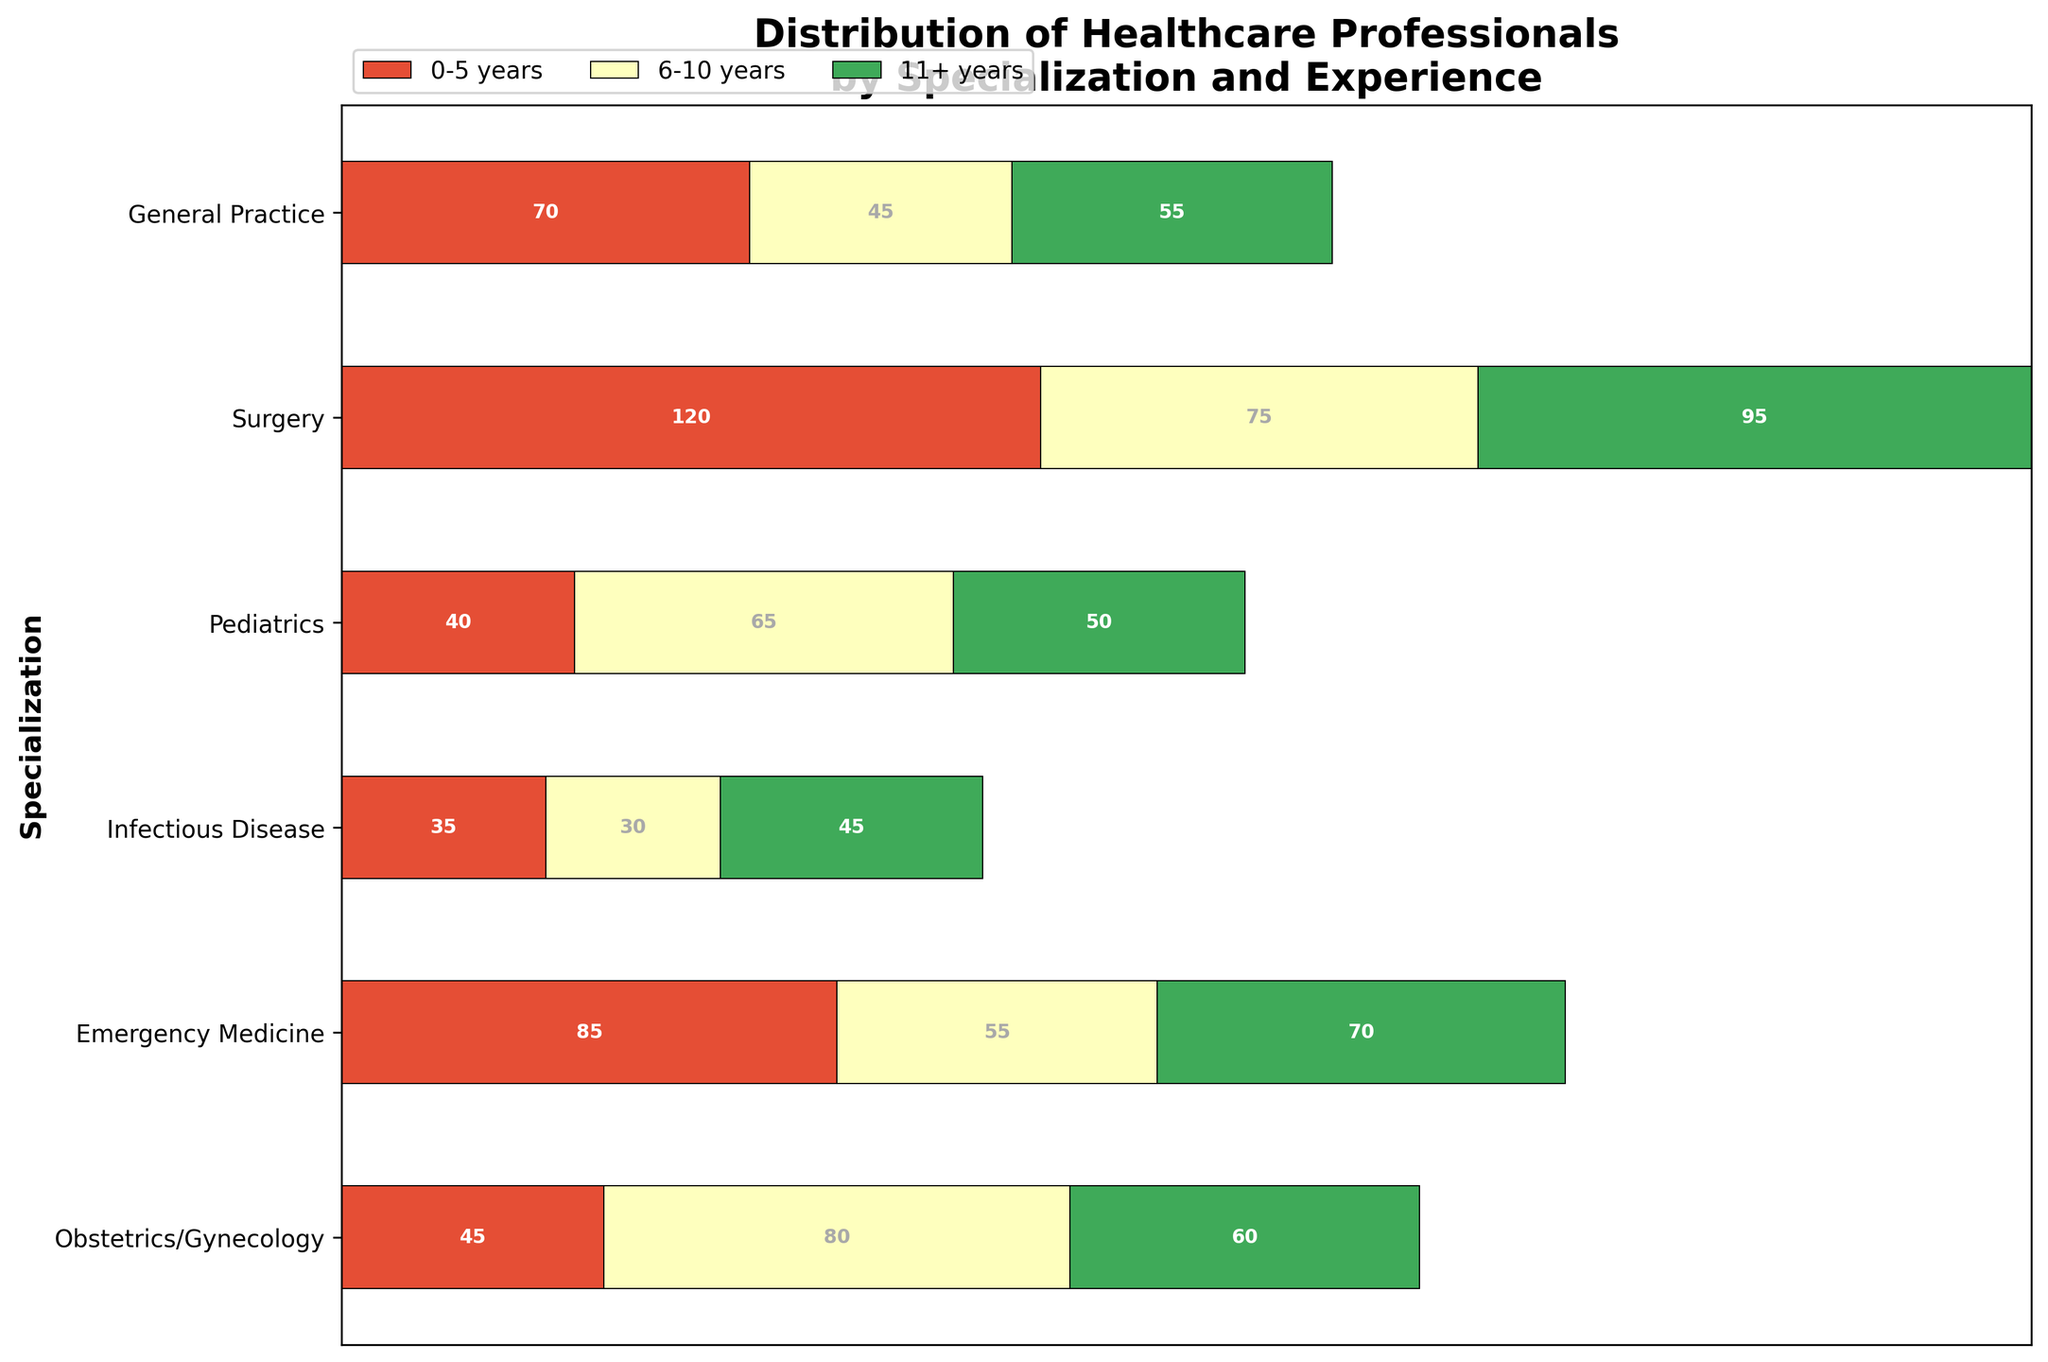What is the title of the figure? The title is usually located at the top of the figure and is a concise summary of what the figure represents.
Answer: Distribution of Healthcare Professionals by Specialization and Experience What color represents healthcare professionals with 0-5 years of experience? In the color legend, different segments denote different experience categories; by referring to the color associated with 0-5 years of experience in the plot, you can identify the color.
Answer: Green Which specialization has the highest count of professionals with 11+ years of experience? By looking at the section in the figure corresponding to 11+ years for each specialization, you can compare their sizes to determine the largest one.
Answer: Surgery How many healthcare professionals with 6-10 years of experience are there in Pediatrics? Observe the bar section for Pediatrics and look up the part colored for 6-10 years of experience; the count will be annotated on that segment.
Answer: 70 Which specialization has the smallest number of professionals with 0-5 years of experience? Compare the segments of each specialization that are colored for 0-5 years; the smallest segment will indicate the specialization with the least professionals in this category.
Answer: Obstetrics/Gynecology What is the total number of professionals in General Practice? Sum the counts of all experience categories within the General Practice bar. This involves adding 120 (0-5 years) + 95 (6-10 years) + 75 (11+ years).
Answer: 290 Which specialization has more professionals: Emergency Medicine or Infectious Disease? Calculate the total number of professionals for each specialization by summing up the counts of all experience categories, then compare the two totals. Emergency Medicine: 70 + 55 + 45 = 170, Infectious Disease: 40 + 50 + 65 = 155.
Answer: Emergency Medicine What is the difference in the number of professionals with 11+ years of experience between General Practice and Pediatrics? Subtract the count of 11+ years in Pediatrics from the count of 11+ years in General Practice (75 - 55).
Answer: 20 Which specialization has the most evenly distributed experience levels? Observe the lengths of segments within each specialization; the most evenly distributed one will have similarly sized segments across 0-5, 6-10, and 11+ years.
Answer: Surgery What is the total number of healthcare professionals shown in the figure? Add up the counts of all specializations and experience levels across the entire figure (120 + 95 + 75 + 45 + 60 + 80 + 85 + 70 + 55 + 40 + 50 + 65 + 70 + 55 + 45 + 35 + 45 + 30).
Answer: 1115 